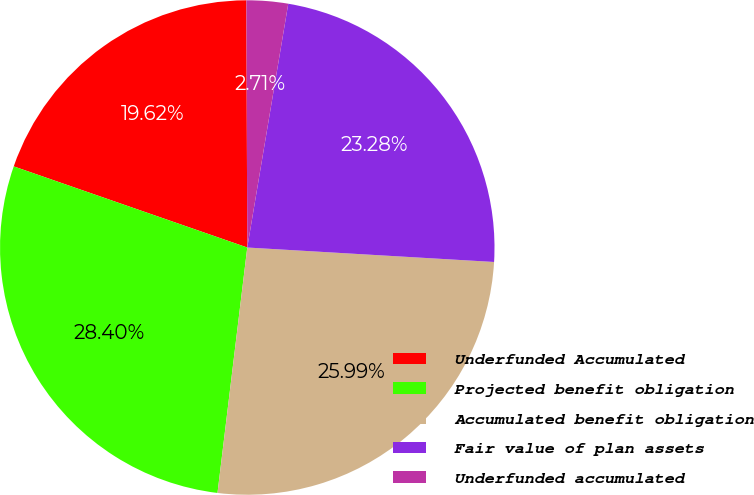Convert chart to OTSL. <chart><loc_0><loc_0><loc_500><loc_500><pie_chart><fcel>Underfunded Accumulated<fcel>Projected benefit obligation<fcel>Accumulated benefit obligation<fcel>Fair value of plan assets<fcel>Underfunded accumulated<nl><fcel>19.62%<fcel>28.4%<fcel>25.99%<fcel>23.28%<fcel>2.71%<nl></chart> 